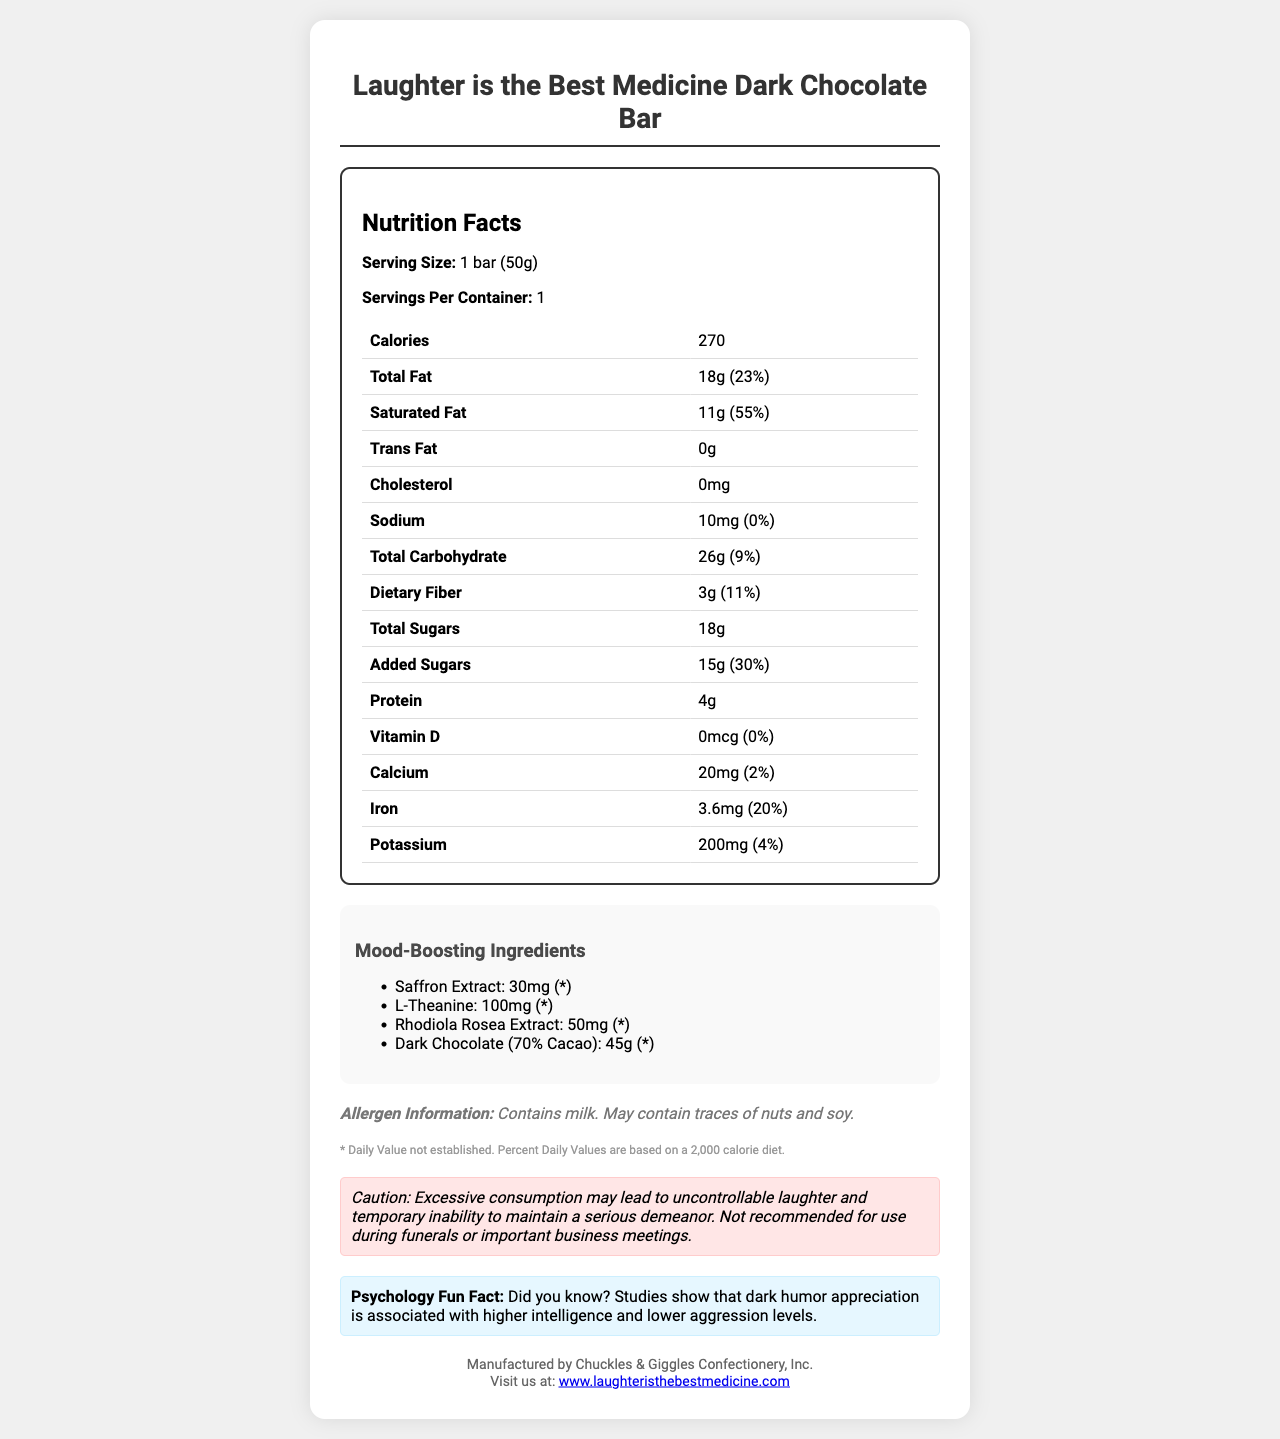what is the serving size of the "Laughter is the Best Medicine" Dark Chocolate Bar? The serving size is directly stated under the Nutrition Facts section.
Answer: 1 bar (50g) how many calories are in one serving of this chocolate bar? The document specifies the calories as 270 per serving.
Answer: 270 how much total fat does the chocolate bar contain? The total fat content is listed as 18 grams.
Answer: 18g What percentage of the daily value of saturated fat is in this chocolate bar? The percentage daily value for saturated fat is provided as 55%.
Answer: 55% how much protein does the chocolate bar contain? The protein content is stated as 4 grams.
Answer: 4g which of the following is not a mood-boosting ingredient in the chocolate bar? A. Saffron Extract B. L-Theanine C. Vitamin D D. Rhodiola Rosea Extract Vitamin D is listed in the nutrition facts but not as a mood-boosting ingredient.
Answer: C how much iron does the chocolate bar provide? The document states the iron content as 3.6 mg, which is 20% of the daily value.
Answer: 3.6mg (20% DV) what is the humorous warning stated on the document? The humorous warning is shown under the "humorous warning" section.
Answer: "Caution: Excessive consumption may lead to uncontrollable laughter and temporary inability to maintain a serious demeanor. Not recommended for use during funerals or important business meetings." does this chocolate bar contain any allergens? The allergen information section notes that it contains milk and may contain traces of nuts and soy.
Answer: Yes describe the main idea of this document. The document covers various details of the chocolate bar including nutritional content, ingredient list, mood-enhancing components, allergen information, and humorous elements.
Answer: The document provides the nutrition facts and ingredient details for the "Laughter is the Best Medicine" dark chocolate bar, highlighting its mood-boosting ingredients, allergens, and offers a humorous warning with a fun psychology fact. is it possible to determine the main source of proteins in the chocolate bar based on this document? The document lists the total protein amount but does not specify which ingredient provides the protein.
Answer: Cannot be determined what is the total carbohydrate content of the chocolate bar? A. 18g B. 26g C. 45g D. 55g The total carbohydrate content is provided as 26 grams.
Answer: B does the chocolate bar contain any cholesterol? It is specified that the cholesterol content is 0mg.
Answer: No what percentage of the daily value of calcium does this chocolate bar provide? The calcium content is listed as 20 mg, which is 2% of the daily value.
Answer: 2% which mood-boosting ingredient has the highest quantity in the chocolate bar? A. Saffron Extract B. L-Theanine C. Rhodiola Rosea Extract D. Dark Chocolate (70% Cacao) Dark Chocolate (70% Cacao) is listed as 45g, which is the highest among the mood-boosting ingredients.
Answer: D how much sodium does the chocolate bar have? The sodium content is listed as 10 mg with 0% of the daily value.
Answer: 10mg (0% DV) what is the percentage of added sugars in the daily value in the chocolate bar? The added sugars have a disclosed daily value of 30%.
Answer: 30% what is the psychology fun fact noted in the document? The psychology fun fact is presented under the fun fact section at the end of the document.
Answer: "Did you know? Studies show that dark humor appreciation is associated with higher intelligence and lower aggression levels." 